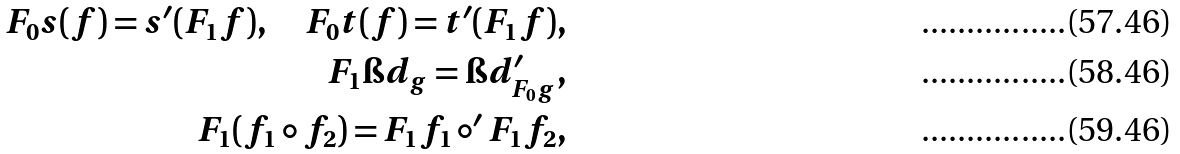Convert formula to latex. <formula><loc_0><loc_0><loc_500><loc_500>F _ { 0 } s ( f ) = s ^ { \prime } ( F _ { 1 } f ) , \quad F _ { 0 } t ( f ) = t ^ { \prime } ( F _ { 1 } f ) , \\ F _ { 1 } \i d _ { g } = \i d ^ { \prime } _ { F _ { 0 } g } , \\ F _ { 1 } ( f _ { 1 } \circ f _ { 2 } ) = F _ { 1 } f _ { 1 } \circ ^ { \prime } F _ { 1 } f _ { 2 } ,</formula> 